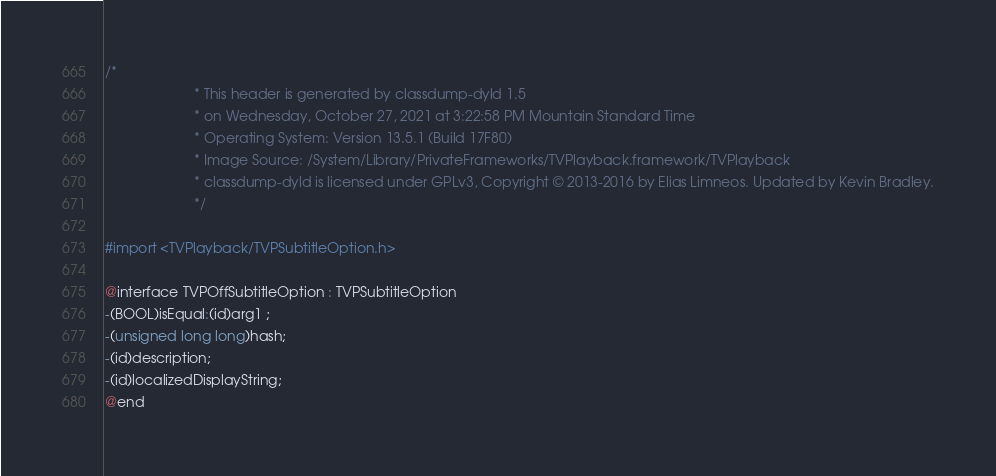Convert code to text. <code><loc_0><loc_0><loc_500><loc_500><_C_>/*
                       * This header is generated by classdump-dyld 1.5
                       * on Wednesday, October 27, 2021 at 3:22:58 PM Mountain Standard Time
                       * Operating System: Version 13.5.1 (Build 17F80)
                       * Image Source: /System/Library/PrivateFrameworks/TVPlayback.framework/TVPlayback
                       * classdump-dyld is licensed under GPLv3, Copyright © 2013-2016 by Elias Limneos. Updated by Kevin Bradley.
                       */

#import <TVPlayback/TVPSubtitleOption.h>

@interface TVPOffSubtitleOption : TVPSubtitleOption
-(BOOL)isEqual:(id)arg1 ;
-(unsigned long long)hash;
-(id)description;
-(id)localizedDisplayString;
@end

</code> 